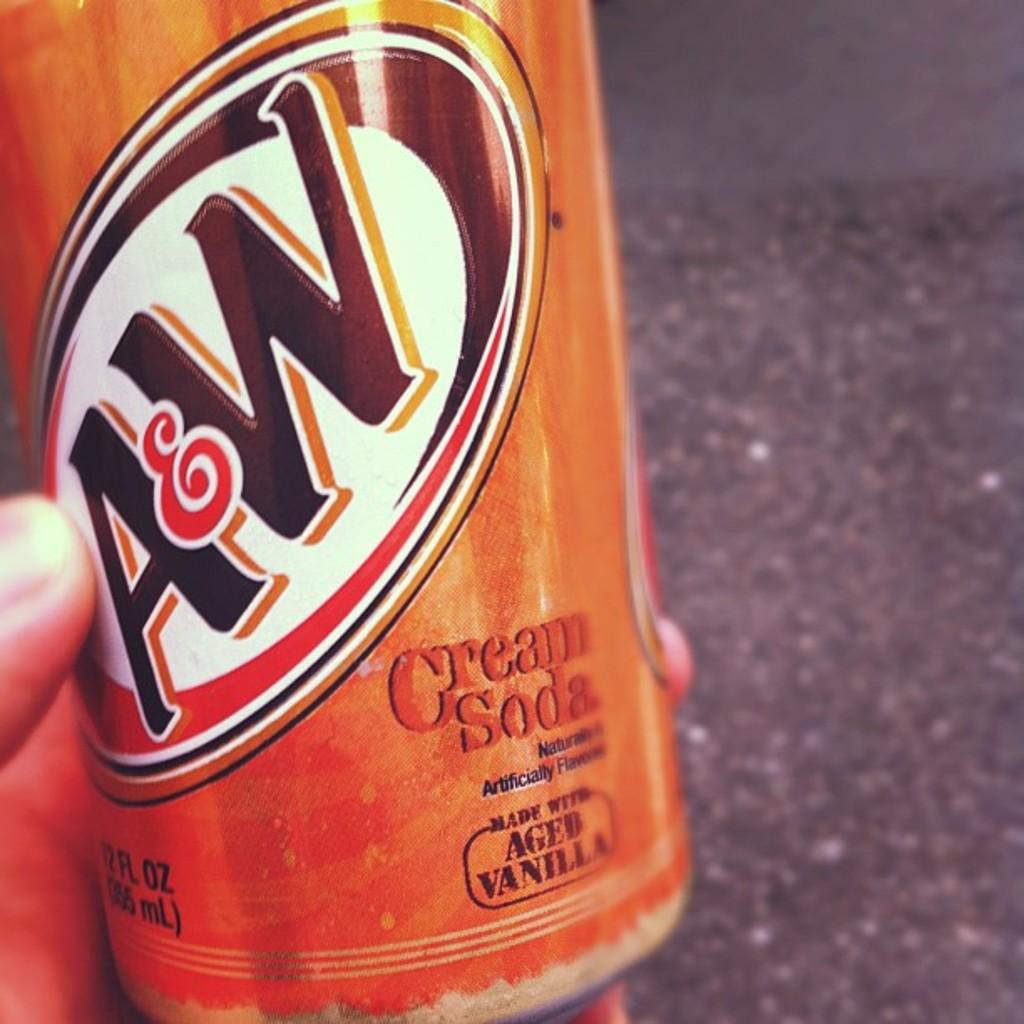Provide a one-sentence caption for the provided image. A&W's Cream Soda is made with aged vanilla and comes in an orange can. 